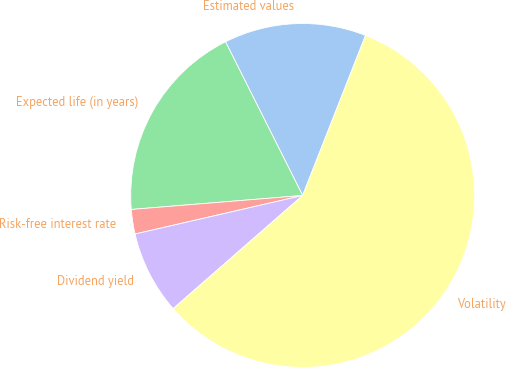Convert chart to OTSL. <chart><loc_0><loc_0><loc_500><loc_500><pie_chart><fcel>Estimated values<fcel>Expected life (in years)<fcel>Risk-free interest rate<fcel>Dividend yield<fcel>Volatility<nl><fcel>13.36%<fcel>18.89%<fcel>2.3%<fcel>7.83%<fcel>57.6%<nl></chart> 